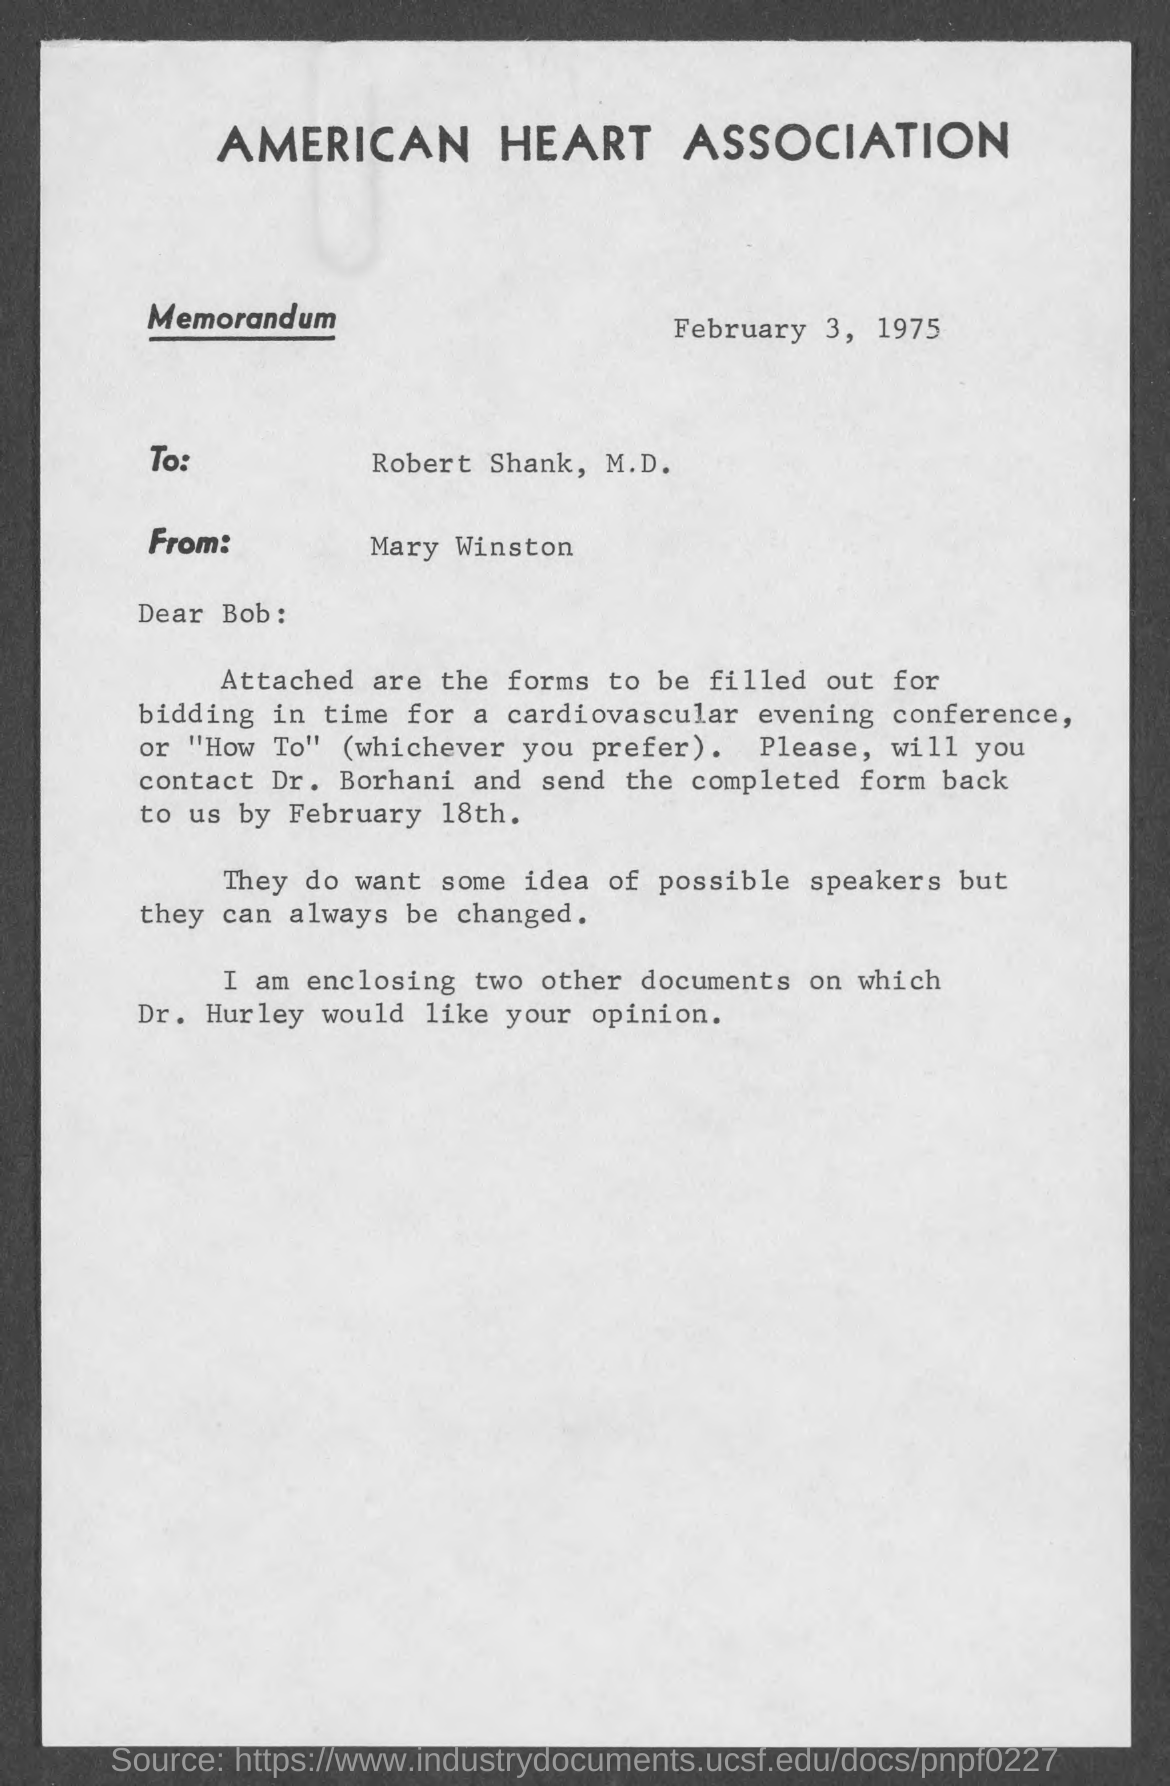Indicate a few pertinent items in this graphic. The memorandum's sender is Mary Winston. The American Heart Association is mentioned in the letterhead. The date mentioned in this memorandum is February 3, 1975. 